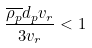<formula> <loc_0><loc_0><loc_500><loc_500>\frac { \overline { \rho _ { p } } d _ { p } v _ { r } } { 3 v _ { r } } < 1</formula> 